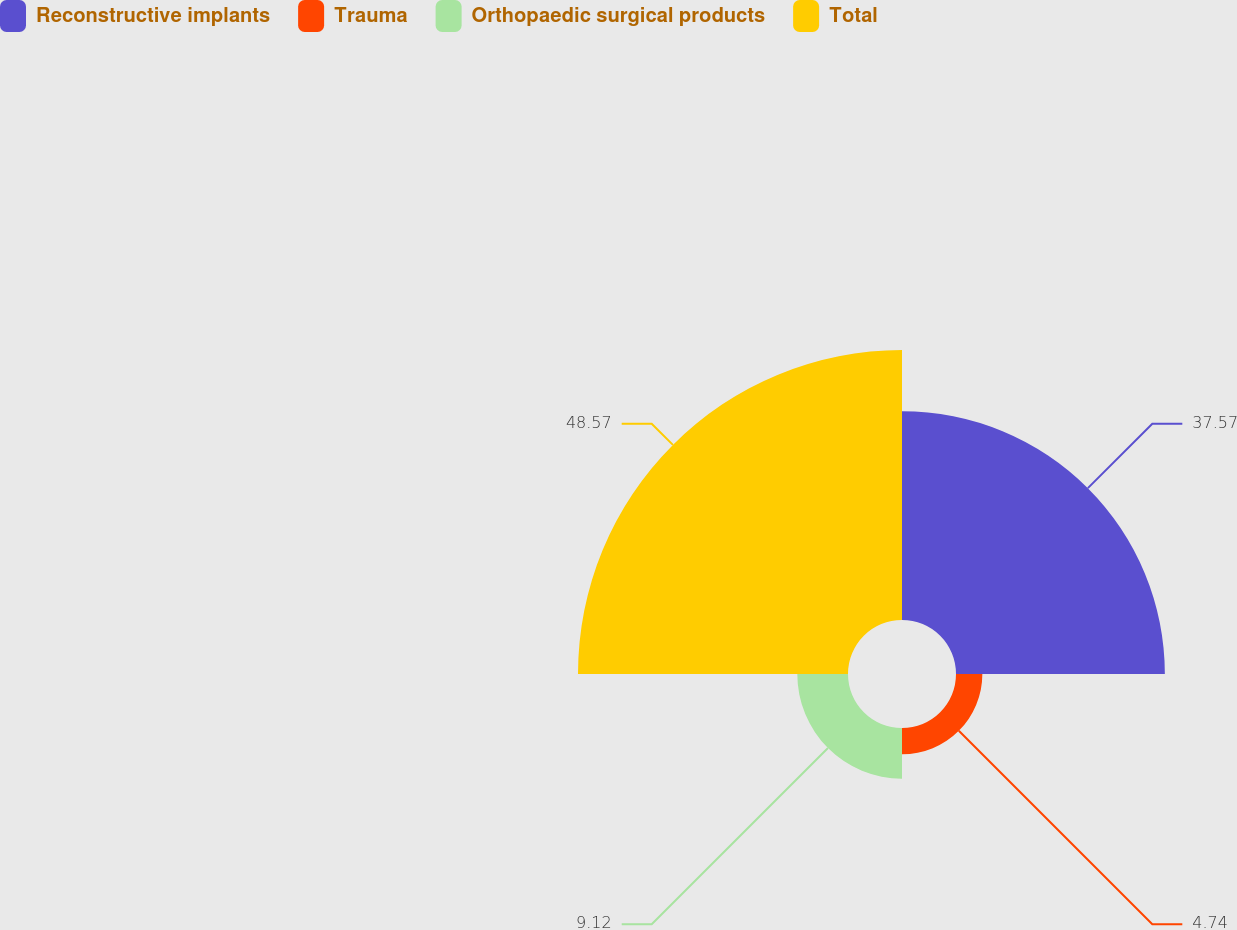<chart> <loc_0><loc_0><loc_500><loc_500><pie_chart><fcel>Reconstructive implants<fcel>Trauma<fcel>Orthopaedic surgical products<fcel>Total<nl><fcel>37.57%<fcel>4.74%<fcel>9.12%<fcel>48.57%<nl></chart> 